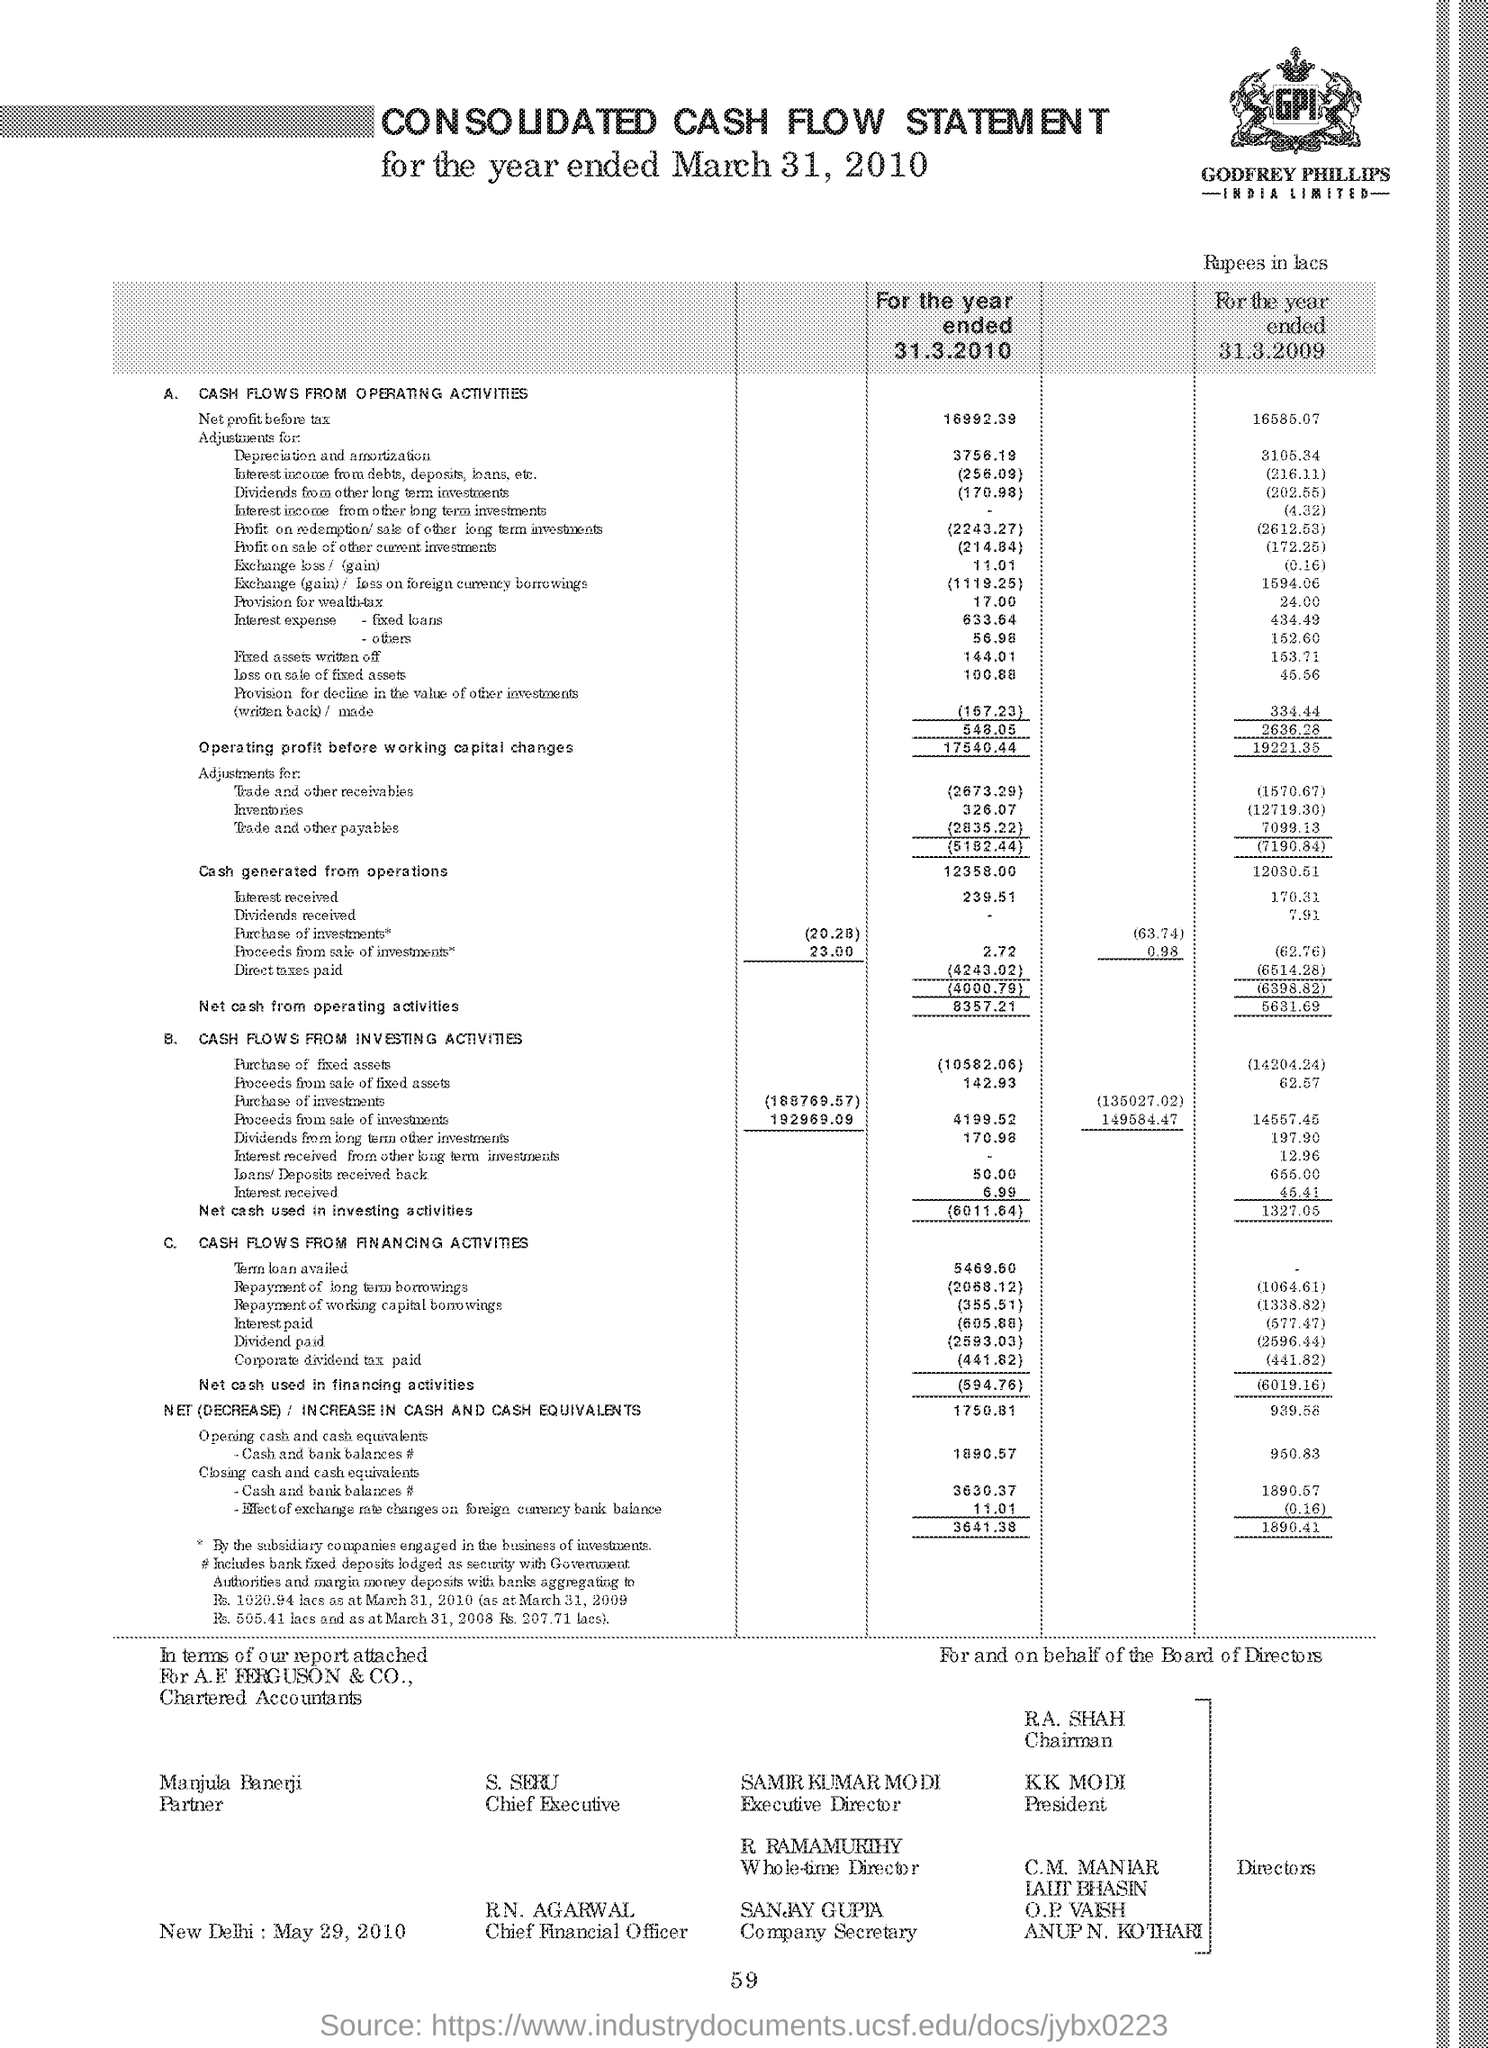Point out several critical features in this image. The Chief Executive is S. Seru. The person named Sanjay Gupta is the Company Secretary. Samir Kumar Modi is the Executive Director of the organization. KK Modi is the President. The Chairman is R.A. Shah. 